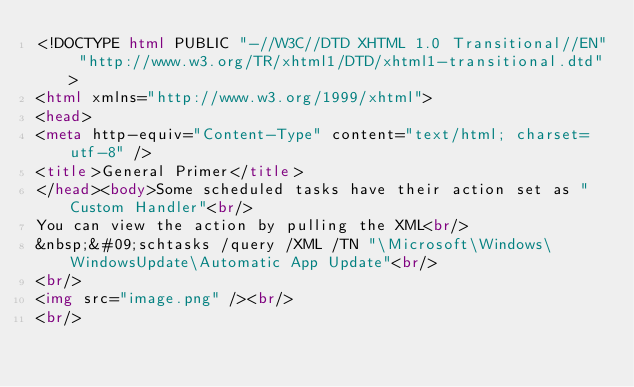Convert code to text. <code><loc_0><loc_0><loc_500><loc_500><_HTML_><!DOCTYPE html PUBLIC "-//W3C//DTD XHTML 1.0 Transitional//EN" "http://www.w3.org/TR/xhtml1/DTD/xhtml1-transitional.dtd">
<html xmlns="http://www.w3.org/1999/xhtml">
<head>
<meta http-equiv="Content-Type" content="text/html; charset=utf-8" />
<title>General Primer</title>
</head><body>Some scheduled tasks have their action set as "Custom Handler"<br/>
You can view the action by pulling the XML<br/>
&nbsp;&#09;schtasks /query /XML /TN "\Microsoft\Windows\WindowsUpdate\Automatic App Update"<br/>
<br/>
<img src="image.png" /><br/>
<br/></code> 